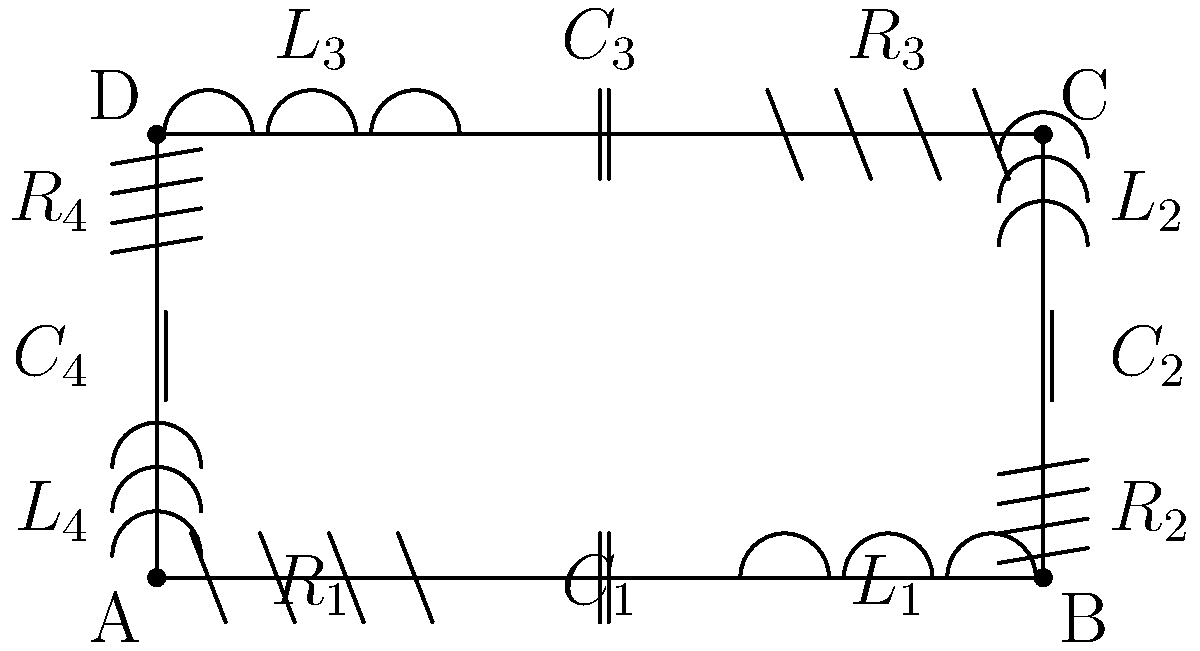Analyze the given circuit schematic, which represents a potential hidden surveillance device. Based on the arrangement of components, what type of surveillance device is this most likely to be, and which component would be critical to altering its operational frequency to avoid detection? To identify the type of surveillance device and the critical component for frequency alteration, let's analyze the circuit step-by-step:

1. Circuit structure:
   The circuit is arranged in a square configuration with four branches, each containing a resistor (R), capacitor (C), and inductor (L) in series.

2. Identifying the device type:
   a) The presence of inductors and capacitors suggests this is an oscillating circuit.
   b) The square arrangement with similar components in each branch resembles a ring oscillator.
   c) Ring oscillators are commonly used in radio frequency (RF) circuits.
   d) In the context of surveillance, this circuit is likely a part of an RF transmitter.

3. Operational principle:
   In a ring oscillator, the signal propagates through each stage, with each introducing a phase shift. When the total phase shift reaches 360°, oscillation occurs.

4. Frequency determination:
   The oscillation frequency (f) is determined by the total delay of all stages:
   $$f = \frac{1}{2n\tau}$$
   where n is the number of stages (4 in this case) and τ is the delay of each stage.

5. Critical component for frequency alteration:
   a) The delay of each stage is influenced by the R, L, and C values.
   b) Among these, the capacitor has the most significant and easily adjustable effect on the frequency.
   c) Changing the capacitance will alter the RC time constant of each stage, directly affecting the oscillation frequency.

Therefore, the capacitors (C1, C2, C3, and C4) are the critical components for altering the operational frequency of this device.
Answer: RF transmitter; Capacitors 